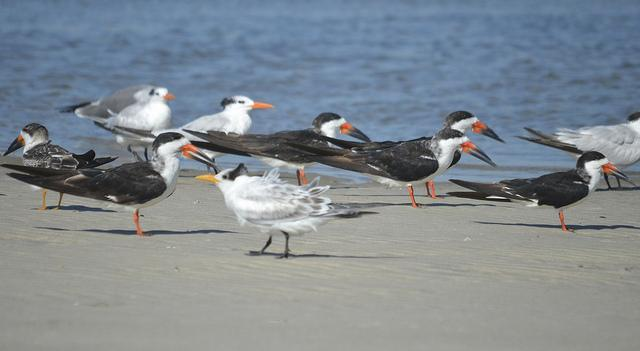What part does this animal have that is absent in humans? wings 